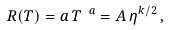Convert formula to latex. <formula><loc_0><loc_0><loc_500><loc_500>R ( T ) = a \, T ^ { \ a } = A \, \eta ^ { k / 2 } \, ,</formula> 